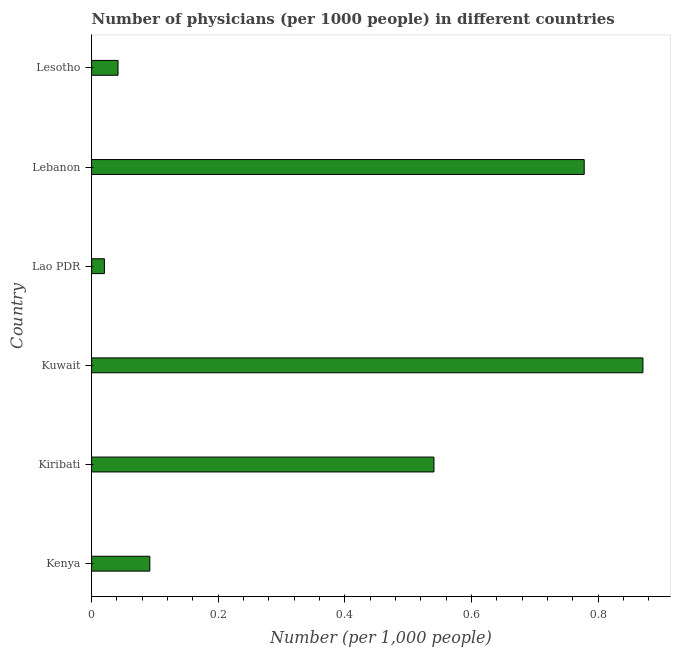What is the title of the graph?
Give a very brief answer. Number of physicians (per 1000 people) in different countries. What is the label or title of the X-axis?
Ensure brevity in your answer.  Number (per 1,0 people). What is the number of physicians in Kuwait?
Provide a short and direct response. 0.87. Across all countries, what is the maximum number of physicians?
Offer a terse response. 0.87. Across all countries, what is the minimum number of physicians?
Your answer should be very brief. 0.02. In which country was the number of physicians maximum?
Your answer should be compact. Kuwait. In which country was the number of physicians minimum?
Give a very brief answer. Lao PDR. What is the sum of the number of physicians?
Provide a succinct answer. 2.34. What is the difference between the number of physicians in Kiribati and Lesotho?
Your response must be concise. 0.5. What is the average number of physicians per country?
Keep it short and to the point. 0.39. What is the median number of physicians?
Provide a succinct answer. 0.32. In how many countries, is the number of physicians greater than 0.2 ?
Make the answer very short. 3. What is the ratio of the number of physicians in Kuwait to that in Lesotho?
Make the answer very short. 20.87. Is the difference between the number of physicians in Lao PDR and Lesotho greater than the difference between any two countries?
Provide a short and direct response. No. What is the difference between the highest and the second highest number of physicians?
Offer a very short reply. 0.09. In how many countries, is the number of physicians greater than the average number of physicians taken over all countries?
Your answer should be very brief. 3. How many countries are there in the graph?
Your answer should be very brief. 6. What is the difference between two consecutive major ticks on the X-axis?
Keep it short and to the point. 0.2. Are the values on the major ticks of X-axis written in scientific E-notation?
Give a very brief answer. No. What is the Number (per 1,000 people) of Kenya?
Your answer should be very brief. 0.09. What is the Number (per 1,000 people) of Kiribati?
Your answer should be compact. 0.54. What is the Number (per 1,000 people) of Kuwait?
Your answer should be very brief. 0.87. What is the Number (per 1,000 people) in Lao PDR?
Keep it short and to the point. 0.02. What is the Number (per 1,000 people) in Lebanon?
Ensure brevity in your answer.  0.78. What is the Number (per 1,000 people) of Lesotho?
Provide a succinct answer. 0.04. What is the difference between the Number (per 1,000 people) in Kenya and Kiribati?
Your answer should be very brief. -0.45. What is the difference between the Number (per 1,000 people) in Kenya and Kuwait?
Your response must be concise. -0.78. What is the difference between the Number (per 1,000 people) in Kenya and Lao PDR?
Offer a very short reply. 0.07. What is the difference between the Number (per 1,000 people) in Kenya and Lebanon?
Give a very brief answer. -0.69. What is the difference between the Number (per 1,000 people) in Kenya and Lesotho?
Give a very brief answer. 0.05. What is the difference between the Number (per 1,000 people) in Kiribati and Kuwait?
Keep it short and to the point. -0.33. What is the difference between the Number (per 1,000 people) in Kiribati and Lao PDR?
Offer a terse response. 0.52. What is the difference between the Number (per 1,000 people) in Kiribati and Lebanon?
Provide a short and direct response. -0.24. What is the difference between the Number (per 1,000 people) in Kiribati and Lesotho?
Provide a short and direct response. 0.5. What is the difference between the Number (per 1,000 people) in Kuwait and Lao PDR?
Provide a short and direct response. 0.85. What is the difference between the Number (per 1,000 people) in Kuwait and Lebanon?
Provide a succinct answer. 0.09. What is the difference between the Number (per 1,000 people) in Kuwait and Lesotho?
Your answer should be compact. 0.83. What is the difference between the Number (per 1,000 people) in Lao PDR and Lebanon?
Keep it short and to the point. -0.76. What is the difference between the Number (per 1,000 people) in Lao PDR and Lesotho?
Provide a short and direct response. -0.02. What is the difference between the Number (per 1,000 people) in Lebanon and Lesotho?
Your response must be concise. 0.74. What is the ratio of the Number (per 1,000 people) in Kenya to that in Kiribati?
Keep it short and to the point. 0.17. What is the ratio of the Number (per 1,000 people) in Kenya to that in Kuwait?
Provide a short and direct response. 0.11. What is the ratio of the Number (per 1,000 people) in Kenya to that in Lao PDR?
Make the answer very short. 4.55. What is the ratio of the Number (per 1,000 people) in Kenya to that in Lebanon?
Your answer should be compact. 0.12. What is the ratio of the Number (per 1,000 people) in Kenya to that in Lesotho?
Keep it short and to the point. 2.2. What is the ratio of the Number (per 1,000 people) in Kiribati to that in Kuwait?
Offer a terse response. 0.62. What is the ratio of the Number (per 1,000 people) in Kiribati to that in Lao PDR?
Offer a very short reply. 26.74. What is the ratio of the Number (per 1,000 people) in Kiribati to that in Lebanon?
Your response must be concise. 0.69. What is the ratio of the Number (per 1,000 people) in Kiribati to that in Lesotho?
Provide a succinct answer. 12.96. What is the ratio of the Number (per 1,000 people) in Kuwait to that in Lao PDR?
Keep it short and to the point. 43.07. What is the ratio of the Number (per 1,000 people) in Kuwait to that in Lebanon?
Ensure brevity in your answer.  1.12. What is the ratio of the Number (per 1,000 people) in Kuwait to that in Lesotho?
Provide a succinct answer. 20.87. What is the ratio of the Number (per 1,000 people) in Lao PDR to that in Lebanon?
Offer a very short reply. 0.03. What is the ratio of the Number (per 1,000 people) in Lao PDR to that in Lesotho?
Provide a succinct answer. 0.48. What is the ratio of the Number (per 1,000 people) in Lebanon to that in Lesotho?
Your response must be concise. 18.65. 